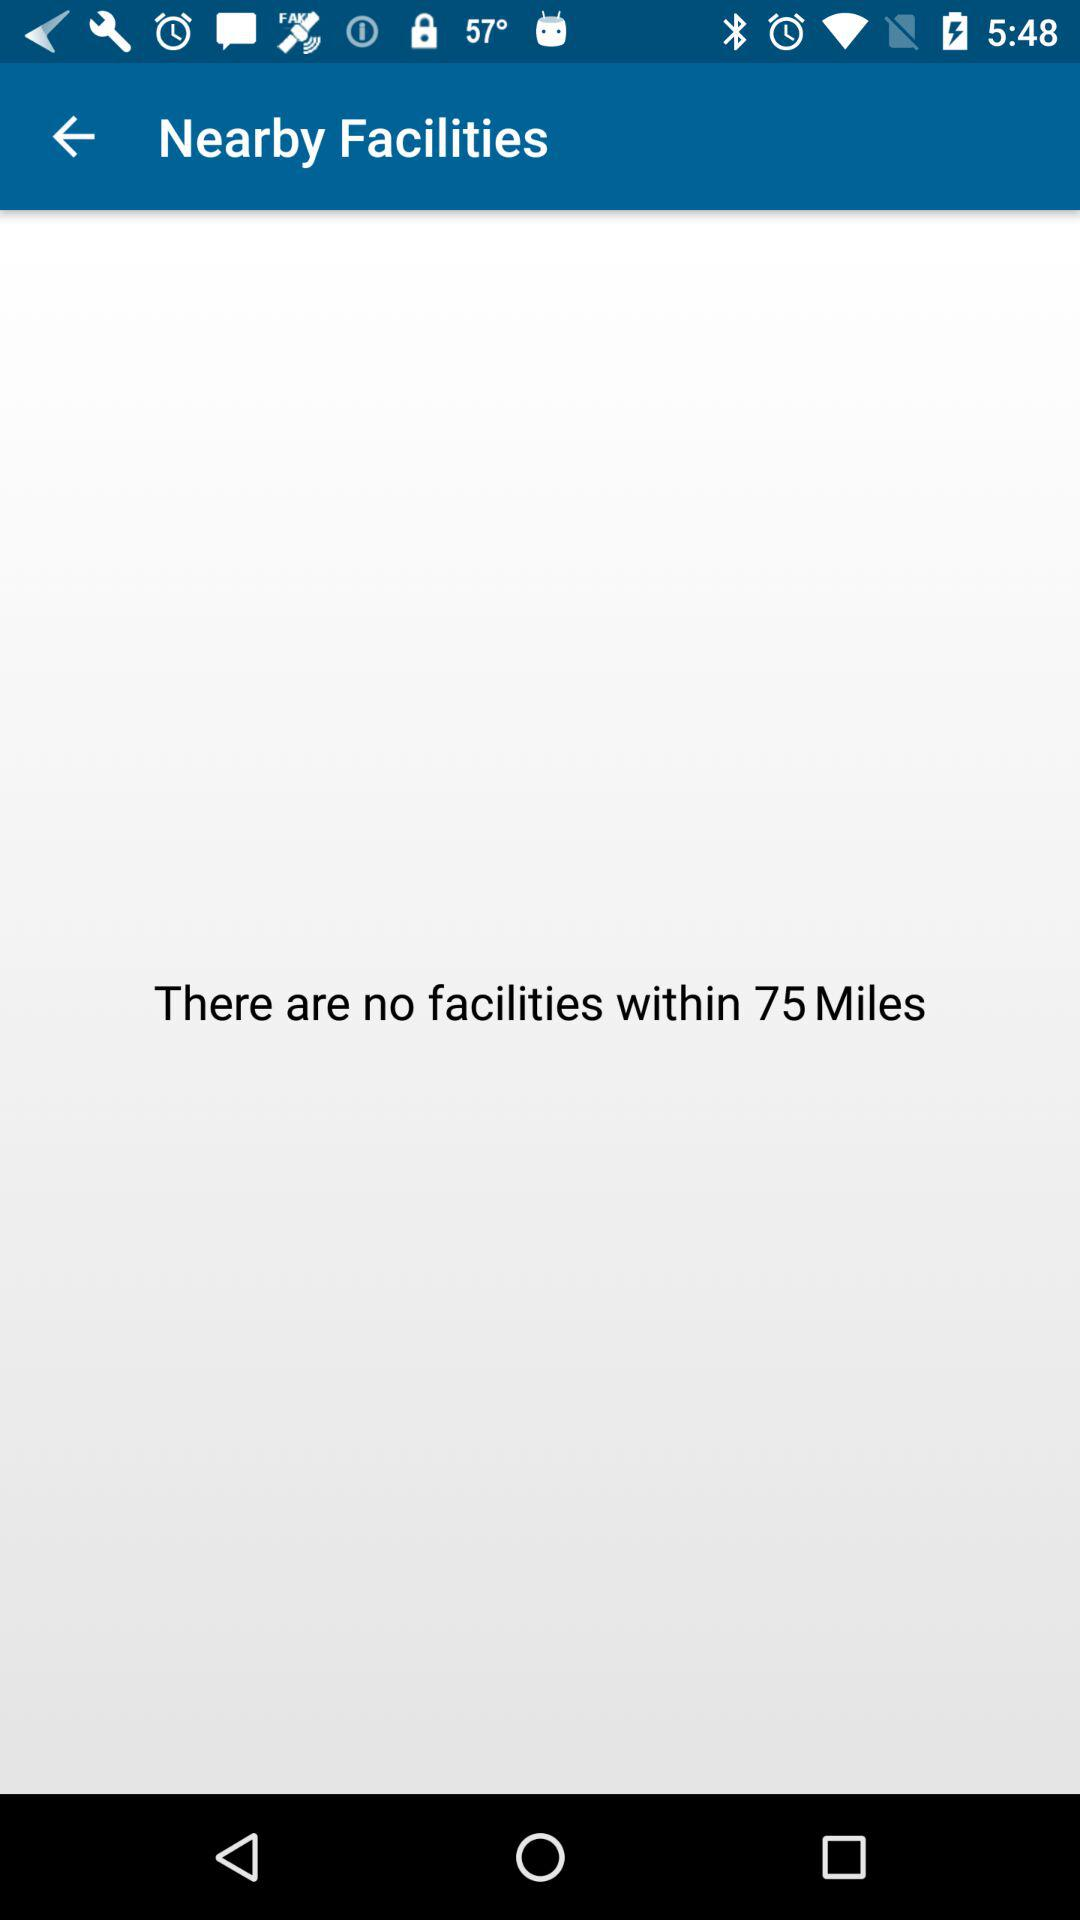How far away is the nearest facility?
Answer the question using a single word or phrase. 75 Miles 